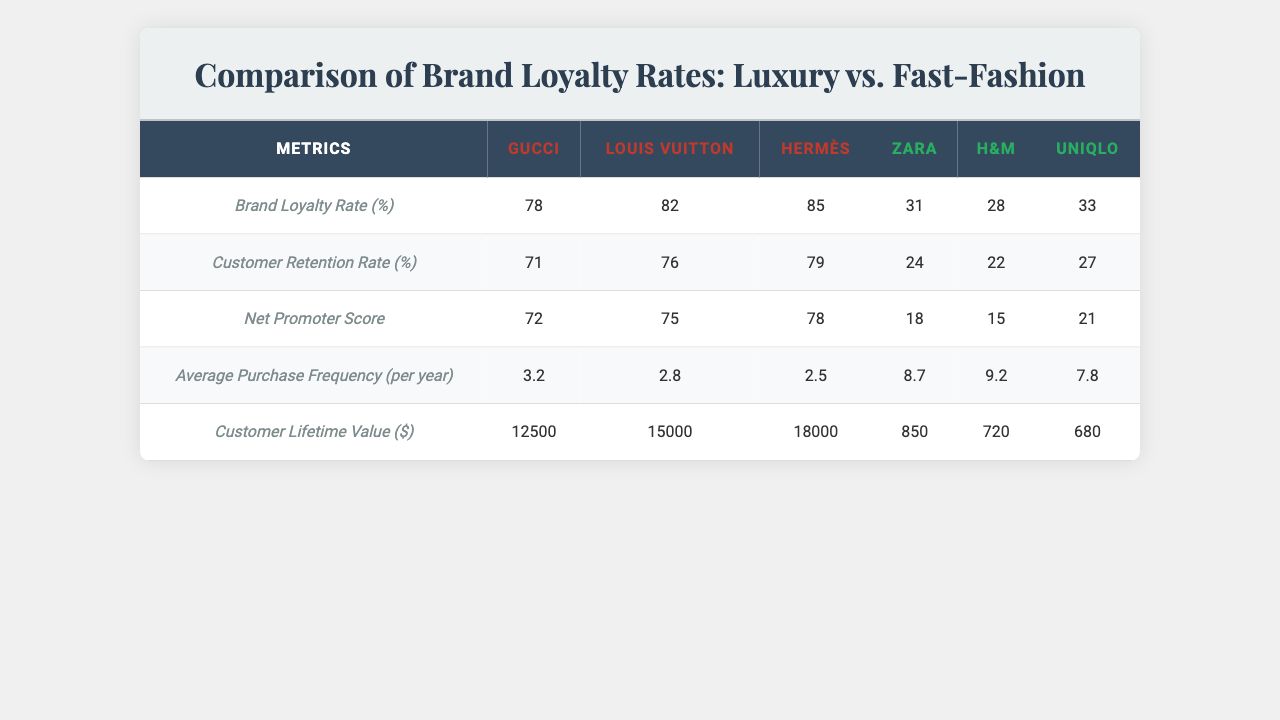What is the Brand Loyalty Rate for Gucci? The table shows a specific metric for each brand, and for Gucci, the Brand Loyalty Rate is listed as 78%.
Answer: 78% Which brand has the highest Customer Retention Rate? Looking at the Customer Retention Rate row in the table, Louis Vuitton has the highest value at 76%.
Answer: Louis Vuitton What is the Net Promoter Score for Zara? The table lists Zara's Net Promoter Score as 24, which can be found in the specific row for this metric.
Answer: 24 What is the average Customer Lifetime Value for luxury brands? To find the average, we add the Customer Lifetime Values for Gucci, Louis Vuitton, and Hermès: (12500 + 15000 + 18000) = 45500. Then, we divide by 3 to get the average: 45500 / 3 = 15166.67.
Answer: 15166.67 Are the Average Purchase Frequencies of fast-fashion brands higher than those of luxury brands? The Average Purchase Frequency for the luxury brands (Gucci, Louis Vuitton, Hermès) averages to (3.2 + 2.8 + 2.5) / 3 = 2.83, compared to the fast-fashion brands (Zara, H&M, Uniqlo) which average to (8.7 + 9.2 + 7.8) / 3 = 8.67. Since 8.67 is greater than 2.83, the statement is true.
Answer: Yes What is the difference in Customer Lifetime Value between the highest luxury brand and the highest fast-fashion brand? The highest Customer Lifetime Value for luxury brands is for Hermès at $18000, and for fast-fashion, it's Zara at $850. The difference is calculated as 18000 - 850 = 17150.
Answer: 17150 Which brand has a Brand Loyalty Rate closest to 80%? Checking the Brand Loyalty Rates, both Louis Vuitton (82%) and Hermès (85%) are closest to 80%. Thus, the answer includes both brands.
Answer: Louis Vuitton and Hermès Is the average Net Promoter Score of luxury brands higher than that of fast-fashion brands? The average for luxury brands is (85 + 79 + 78) / 3 = 80.67. The average for fast-fashion brands is (24 + 22 + 27) / 3 = 24.33. Since 80.67 is greater than 24.33, the assertion that luxury brands have a higher average Net Promoter Score is true.
Answer: Yes What is the combined Customer Lifetime Value for all fast-fashion brands? To find the combined value, we sum up the Customer Lifetime Values: 850 + 720 + 680 = 2250.
Answer: 2250 Among the brands listed, which has the lowest Average Purchase Frequency? Looking at the Average Purchase Frequency, Hermès has the lowest at 2.5.
Answer: Hermès 